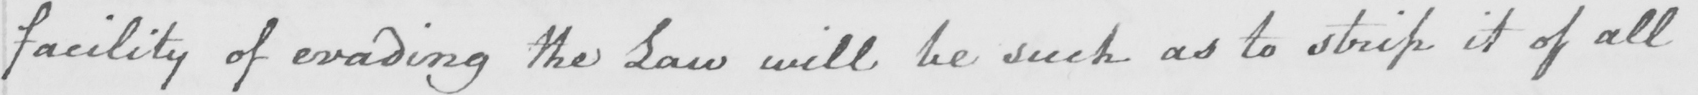Please transcribe the handwritten text in this image. facility of evading the Law will be such as to strip it of all 